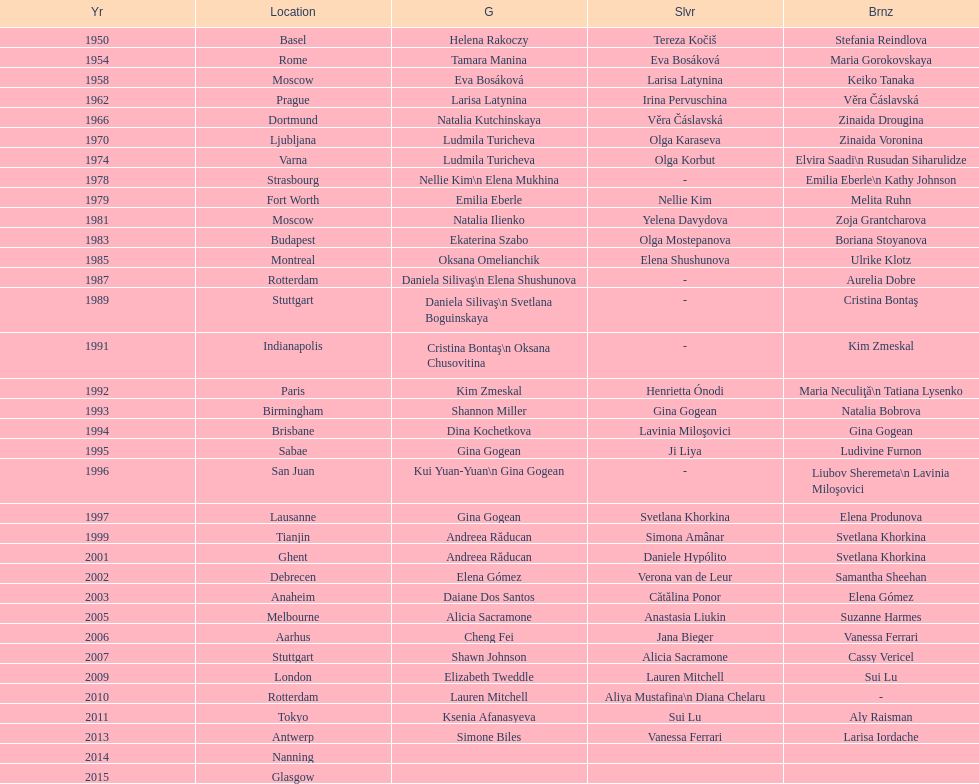How many times was the world artistic gymnastics championships held in the united states? 3. 